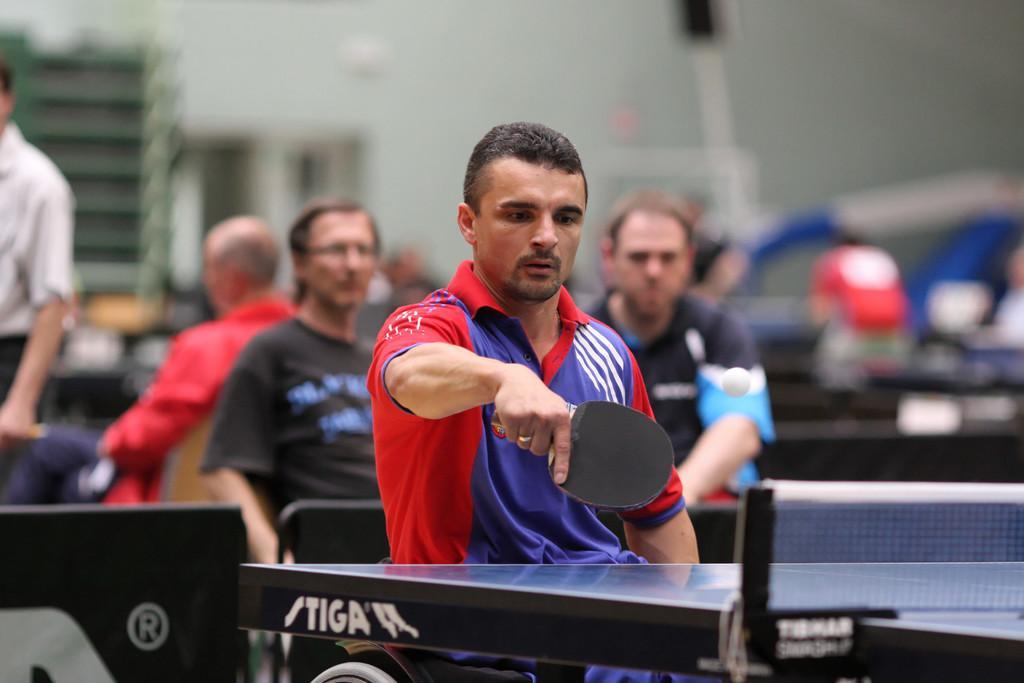Can you describe this image briefly? In this image, In the middle there is a table which is in black color, There is a man sitting and he is holding a black color object, In the background there are some people sitting and watching the match and there is a wall which is in white color. 